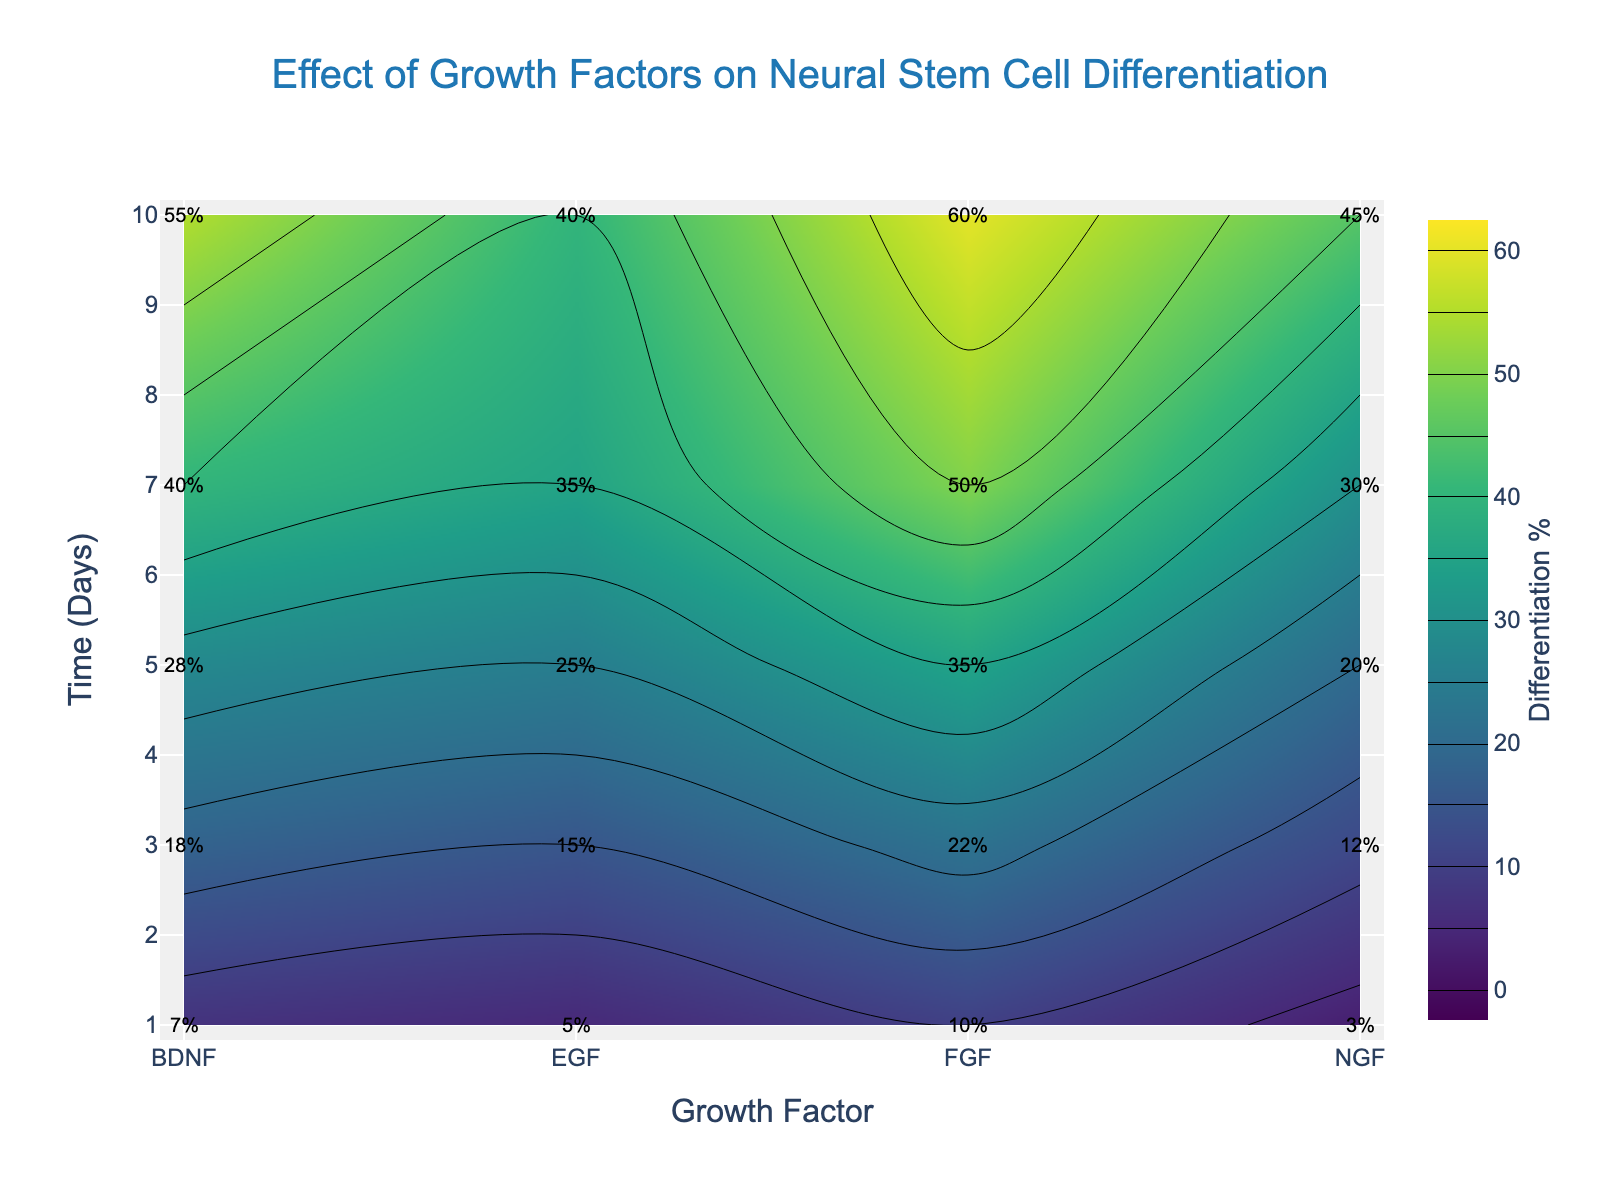What is the title of the plot? The title is displayed at the top center of the plot, it reads "Effect of Growth Factors on Neural Stem Cell Differentiation".
Answer: Effect of Growth Factors on Neural Stem Cell Differentiation Which growth factor shows the highest differentiation percentage at day 10? By examining the contour labels at day 10 on the y-axis, FGF has the highest differentiation percentage marked with 60%.
Answer: FGF What is the differentiation percentage of NGF on day 7? Look for NGF along the x-axis and follow it to day 7 on the y-axis, the label shows 30%.
Answer: 30% Which growth factor has the lowest differentiation at day 3? On day 3 (y-axis), check the labels for each growth factor. NGF has the lowest at 12%.
Answer: NGF Between BDNF and EGF, which growth factor shows higher differentiation at day 1? Find day 1 on the y-axis and compare the labels for BDNF and EGF. BDNF shows 7% while EGF shows 5%.
Answer: BDNF What is the average differentiation percentage of EGF over the 10 days? Add the differentiation percentages for EGF: 5, 15, 25, 35, 40. The total is 120. There are 5 data points, so the average is 120 / 5.
Answer: 24% Which two growth factors exhibit the closest differentiation percentages at day 5? At day 5 on the y-axis, compare percentages. EGF (25%) and NGF (20%) are the closest. The difference is (25 - 20) = 5.
Answer: EGF and NGF How does the differentiation pattern of FGF compare to that of BDNF over time? Examine the contours for both FGF and BDNF. FGF consistently shows higher differentiation than BDNF at all time points, with the gap increasing over time.
Answer: FGF shows higher differentiation Which growth factor has the most rapid increase in differentiation percentage from day 1 to day 7? Calculate the increase for each growth factor: EGF (35-5=30), FGF (50-10=40), NGF (30-3=27), BDNF (40-7=33). FGF has the highest increase.
Answer: FGF At what time does BDNF show the highest rate of increase in differentiation percentage? By examining the contour labels, BDNF shows an increase from 7% at day 1 to 18% at day 3. The increase of 11% over 2 days is the highest rate.
Answer: Day 1 to Day 3 